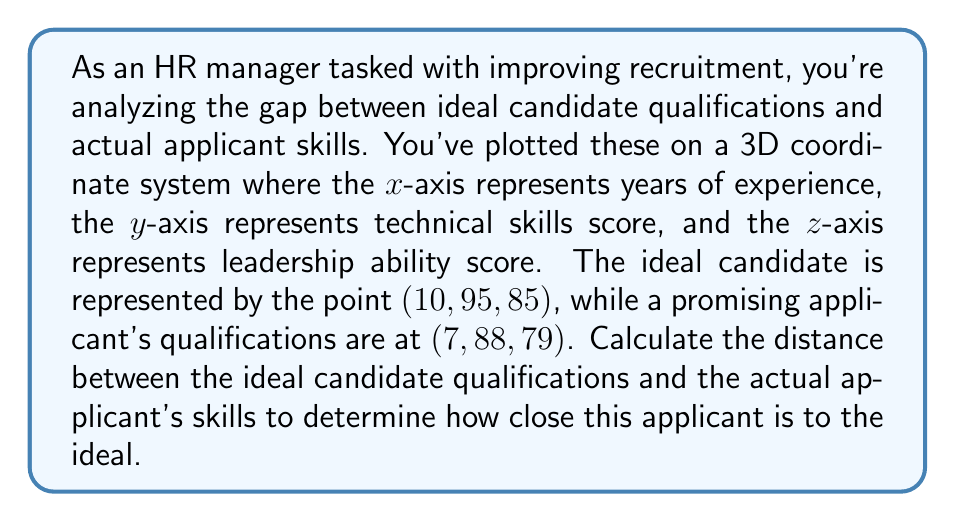Solve this math problem. To solve this problem, we need to use the distance formula in three-dimensional space. The distance between two points in 3D space is given by:

$$ d = \sqrt{(x_2 - x_1)^2 + (y_2 - y_1)^2 + (z_2 - z_1)^2} $$

Where $(x_1, y_1, z_1)$ represents the coordinates of the first point (ideal candidate) and $(x_2, y_2, z_2)$ represents the coordinates of the second point (actual applicant).

Let's substitute the given values:

$(x_1, y_1, z_1) = (10, 95, 85)$ (ideal candidate)
$(x_2, y_2, z_2) = (7, 88, 79)$ (actual applicant)

Now, let's calculate each term inside the square root:

$(x_2 - x_1)^2 = (7 - 10)^2 = (-3)^2 = 9$
$(y_2 - y_1)^2 = (88 - 95)^2 = (-7)^2 = 49$
$(z_2 - z_1)^2 = (79 - 85)^2 = (-6)^2 = 36$

Adding these terms:

$$ d = \sqrt{9 + 49 + 36} = \sqrt{94} $$

To simplify this, we can take the square root:

$$ d = \sqrt{94} \approx 9.70 $$

This value represents the distance between the ideal candidate qualifications and the actual applicant's skills in our 3D qualification space.
Answer: $$ d = \sqrt{94} \approx 9.70 $$ 